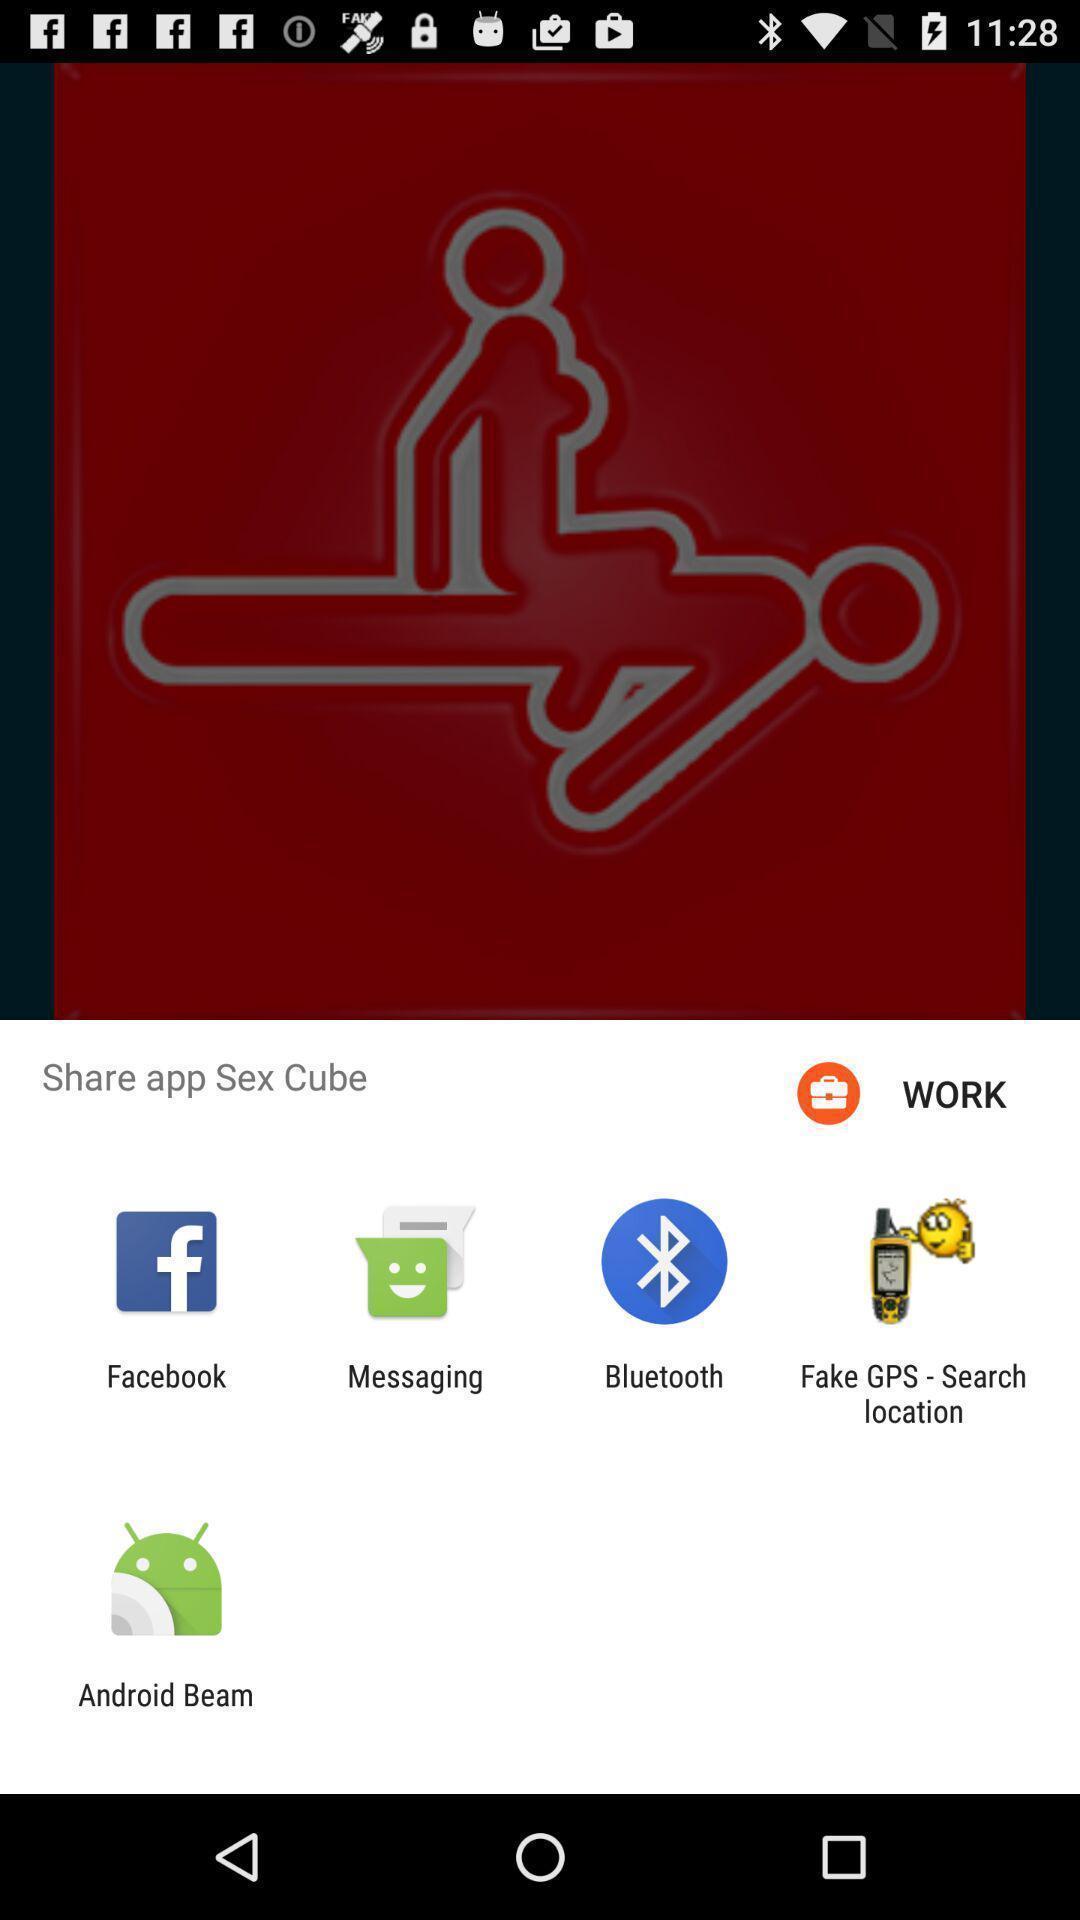Tell me about the visual elements in this screen capture. Share options page of a social app. 